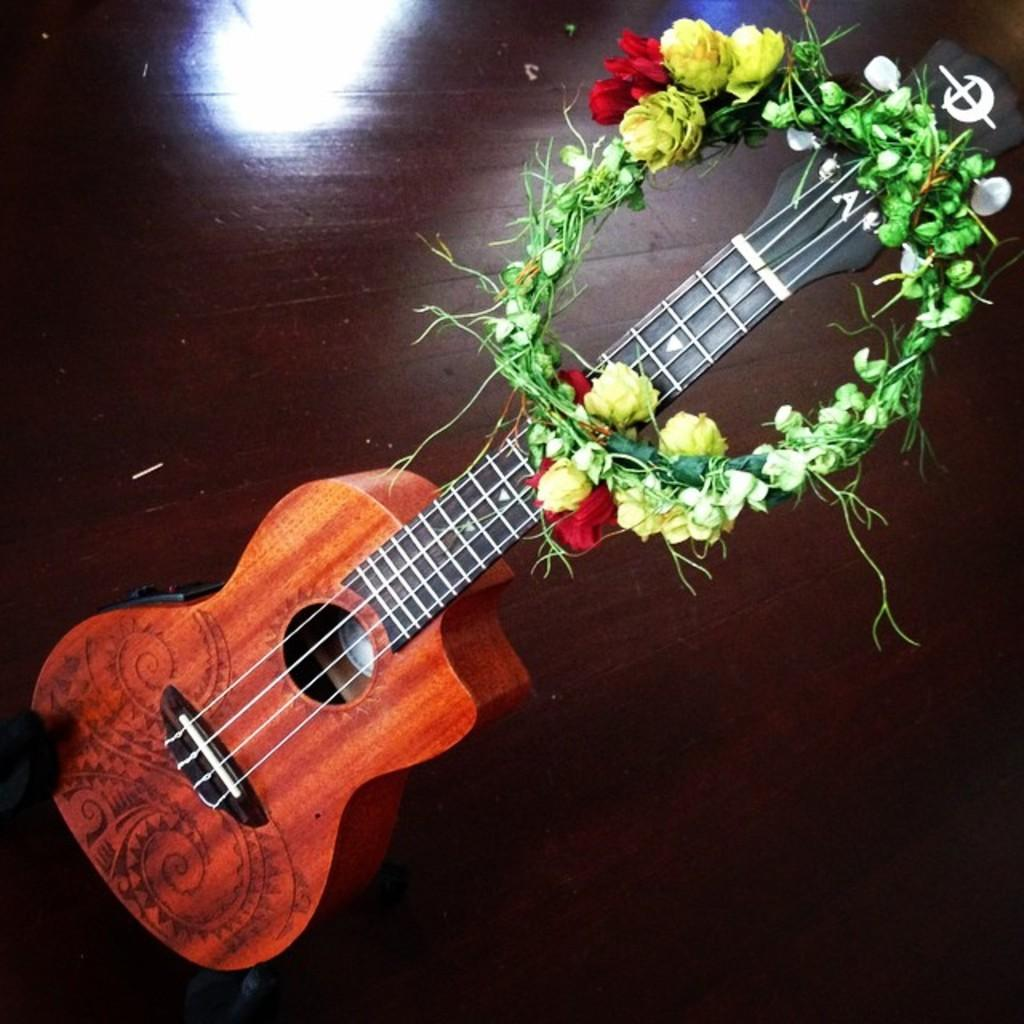What musical instrument is present in the image? There is a guitar with strings in the image. What can be observed about the guitar's appearance? The guitar has a design on it. What type of accessory is present in the image? There is a flower crown with yellow and red flowers in the image. Where is the guitar located in the image? The guitar is placed on the floor. What type of memory is stored inside the guitar in the image? There is no memory storage device present in the guitar; it is a musical instrument. 